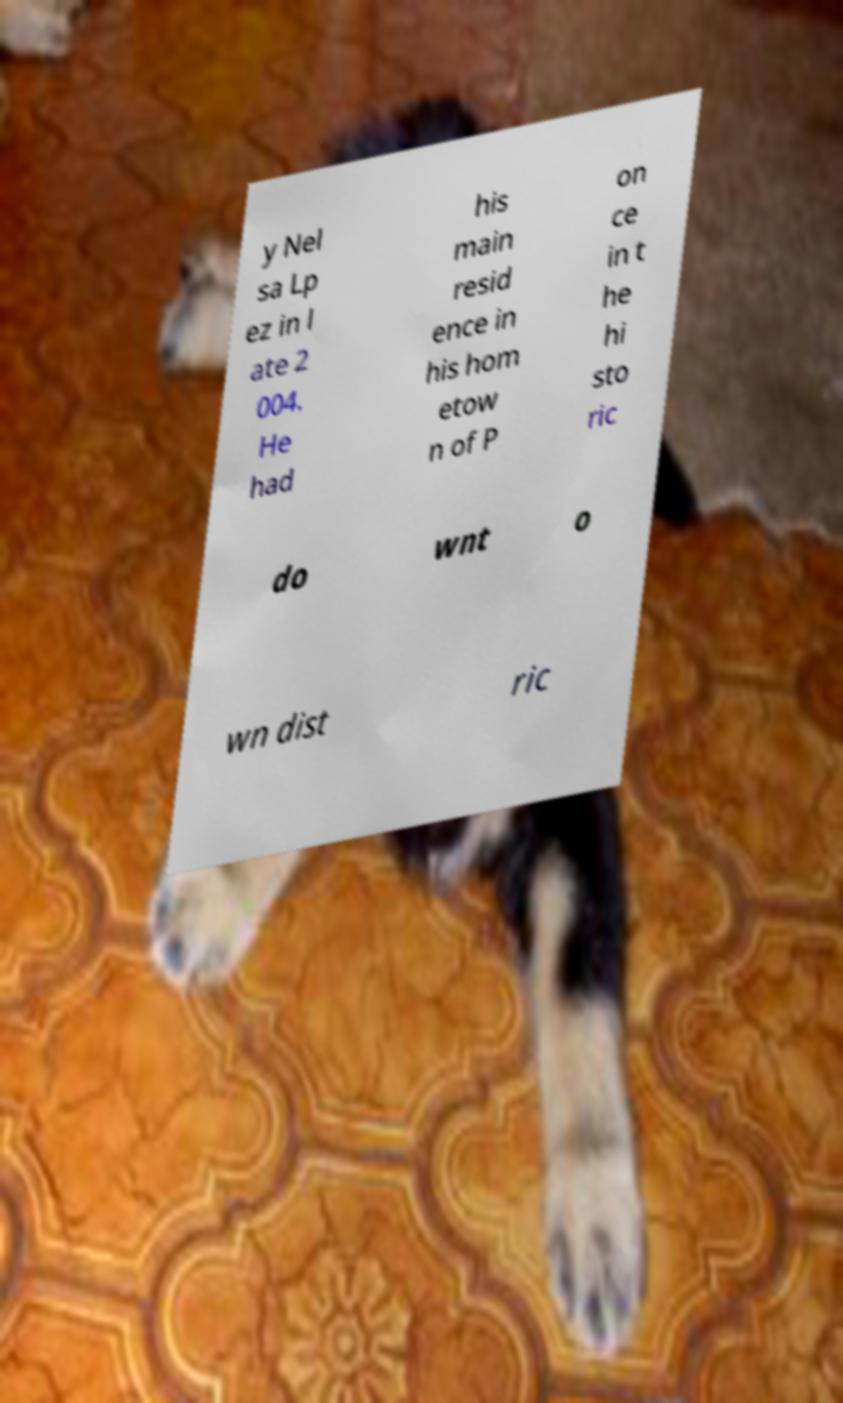Could you extract and type out the text from this image? y Nel sa Lp ez in l ate 2 004. He had his main resid ence in his hom etow n of P on ce in t he hi sto ric do wnt o wn dist ric 